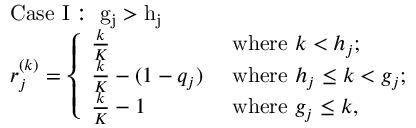<formula> <loc_0><loc_0><loc_500><loc_500>\begin{array} { r l } & { C a s e I \colon g _ { j } > h _ { j } } \\ & { r _ { j } ^ { ( k ) } = \left \{ \begin{array} { l l } { \frac { k } { K } } & { w h e r e k < h _ { j } ; } \\ { \frac { k } { K } - ( 1 - q _ { j } ) } & { w h e r e h _ { j } \leq k < g _ { j } ; } \\ { \frac { k } { K } - 1 } & { w h e r e g _ { j } \leq k , } \end{array} } \end{array}</formula> 